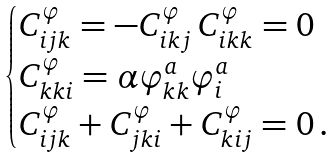Convert formula to latex. <formula><loc_0><loc_0><loc_500><loc_500>\begin{cases} C ^ { \varphi } _ { i j k } = - C ^ { \varphi } _ { i k j } \, C ^ { \varphi } _ { i k k } = 0 \\ C ^ { \varphi } _ { k k i } = \alpha \varphi ^ { a } _ { k k } \varphi ^ { a } _ { i } \\ C ^ { \varphi } _ { i j k } + C ^ { \varphi } _ { j k i } + C ^ { \varphi } _ { k i j } = 0 \, . \end{cases}</formula> 